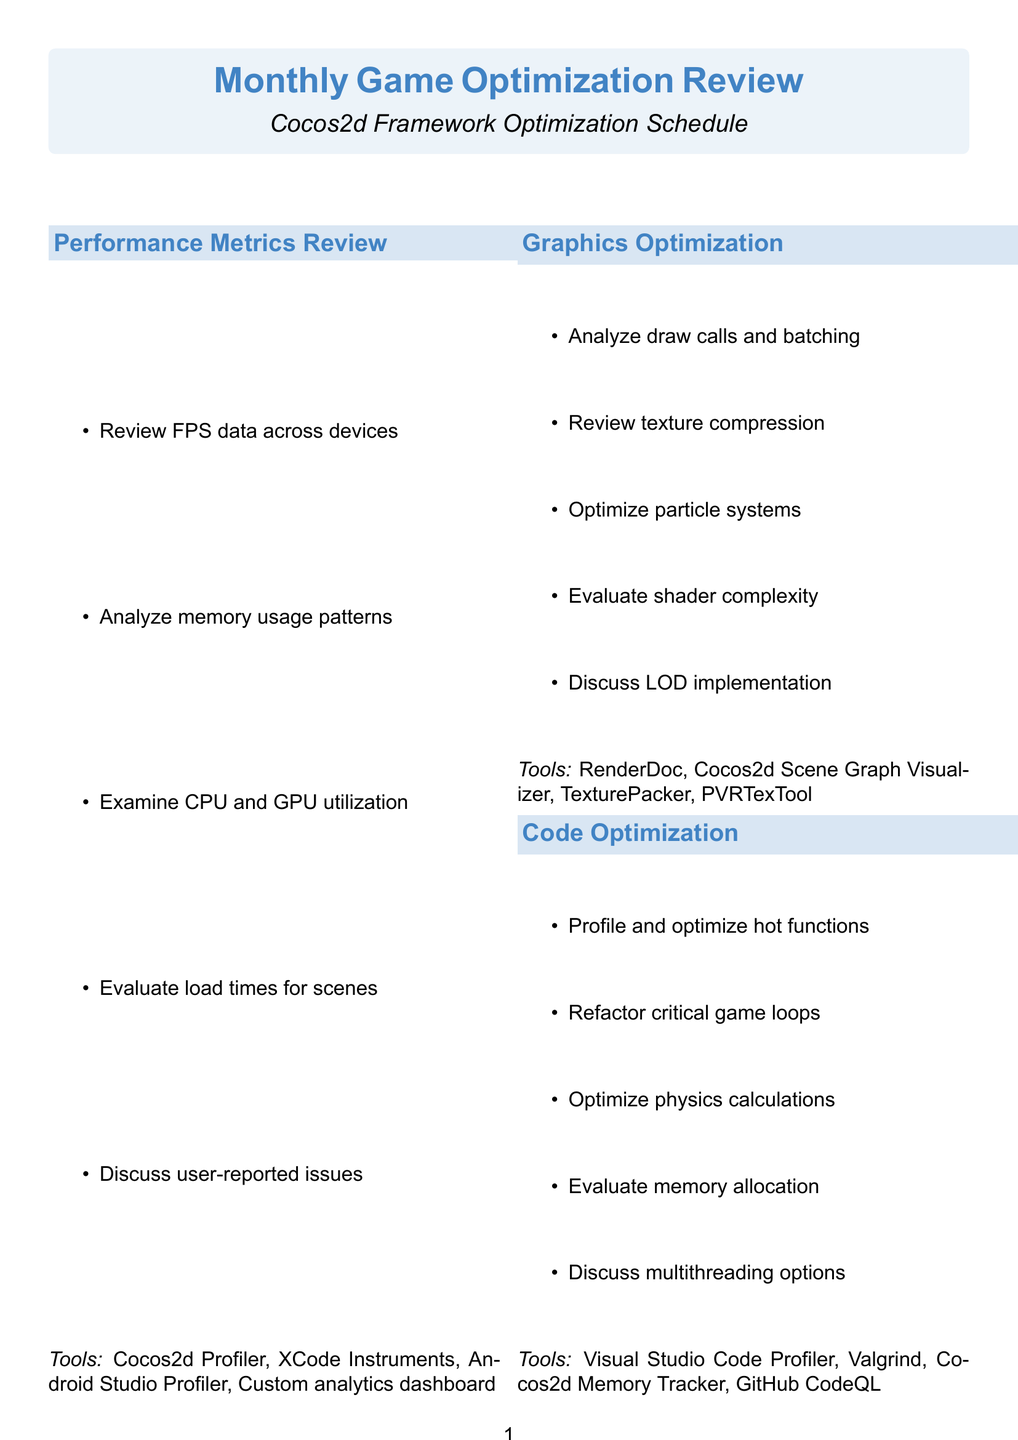What is the session name dedicated to profiling hot functions? The session that focuses on profiling hot functions is named "Code Optimization."
Answer: Code Optimization How many tools are listed under the Graphics Optimization session? There are four tools mentioned in the Graphics Optimization session.
Answer: 4 What is one of the activities in the Network Optimization session? The Network Optimization session includes multiple activities, one of which is to analyze network traffic patterns.
Answer: Analyze network traffic patterns Which tool is used for analyzing crash reports? The tool mentioned for analyzing crash reports is Firebase Crashlytics.
Answer: Firebase Crashlytics What does the Asset Pipeline Optimization session evaluate regarding large maps? The Asset Pipeline Optimization session evaluates streaming strategies for large maps.
Answer: Streaming strategies for large maps Which session focuses on user feedback and app store reviews? The session that reviews player feedback and app store reviews is named "Target Areas Identification."
Answer: Target Areas Identification What is the purpose of the monthly game optimization review sessions? The purpose is to optimize various aspects of the game using tools and activities tailored for performance improvements.
Answer: Optimize various aspects of the game What is the primary focus of the session titled "Graphics Optimization"? The primary focus is on analyzing draw calls and batching efficiency along with other graphics-related tasks.
Answer: Analyzing draw calls and batching efficiency 